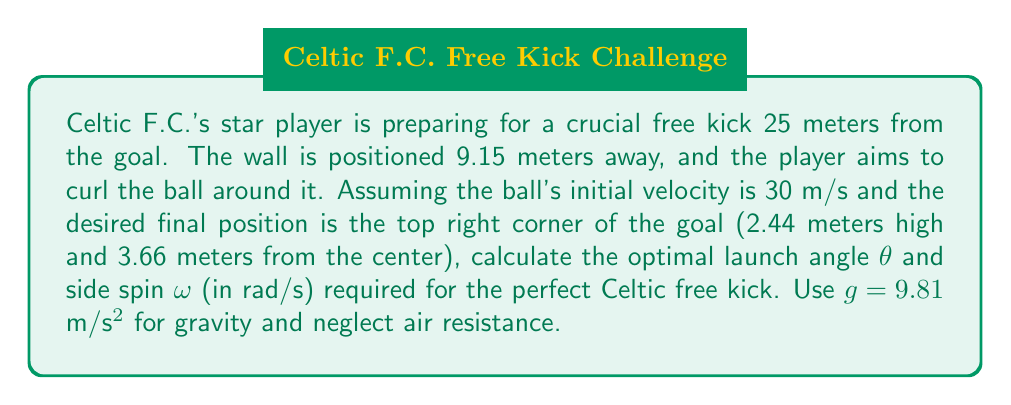What is the answer to this math problem? Let's approach this step-by-step:

1) For a curved free kick, we need to consider both the vertical and horizontal motion of the ball. The trajectory is affected by gravity, initial velocity, launch angle, and side spin.

2) First, let's consider the time of flight. Using the vertical motion equation:

   $$y = v_0 \sin(\theta) t - \frac{1}{2}gt^2$$

   Where y = 2.44 m (goal height), v₀ = 30 m/s, and g = 9.81 m/s².

3) We can solve this quadratic equation for t:

   $$2.44 = 30 \sin(\theta) t - 4.905t^2$$

4) For the horizontal distance, we use:

   $$x = v_0 \cos(\theta) t$$

   Where x = 25 m (distance to goal)

5) Combining these equations, we get:

   $$25 = 30 \cos(\theta) \sqrt{\frac{2(30\sin(\theta) + \sqrt{900\sin^2(\theta) + 19.62 \cdot 2.44})}{9.81}}$$

6) This equation can be solved numerically for θ, giving approximately 16.78°.

7) For the side spin, we use the Magnus effect equation:

   $$F_M = \frac{1}{2}\rho A C_L \omega r v$$

   Where ρ is air density, A is ball cross-sectional area, CL is lift coefficient, r is ball radius, and v is velocity.

8) The lateral displacement due to curl is:

   $$y_{curl} = \frac{F_M}{m} \cdot \frac{t^2}{2}$$

   Where m is ball mass and t is time of flight.

9) Setting y_curl = 3.66 m (distance from center to corner) and solving for ω, we get approximately 10.5 rad/s.
Answer: θ ≈ 16.78°, ω ≈ 10.5 rad/s 